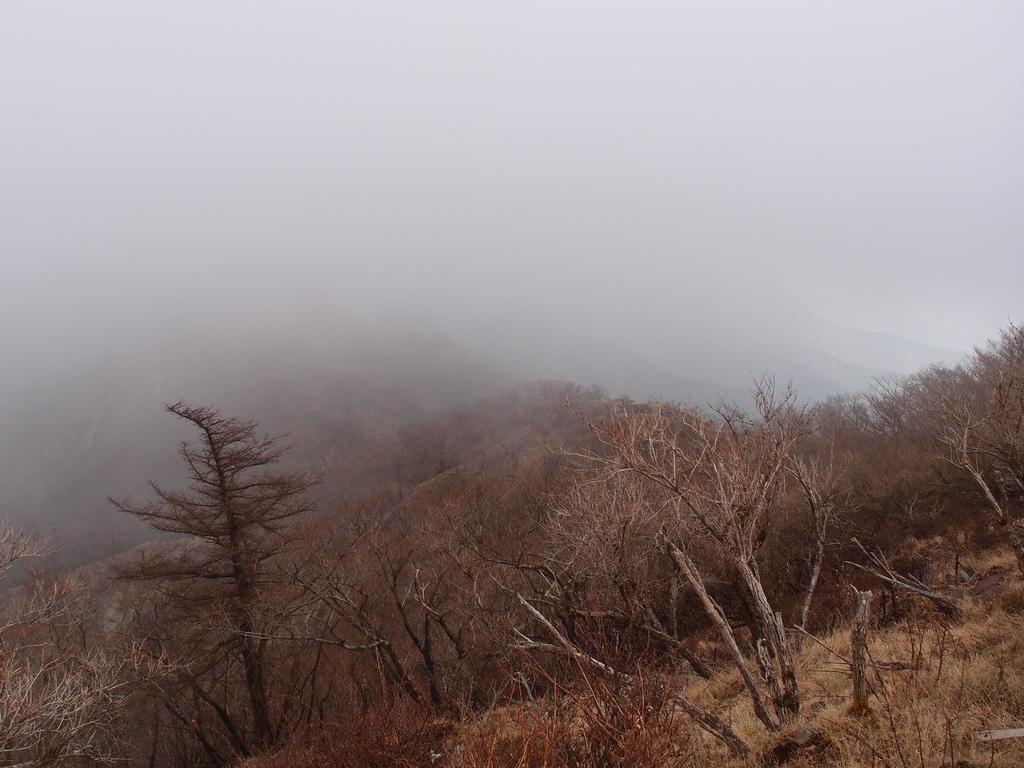Describe this image in one or two sentences. In this image we can see few hills. There are many trees in the image. We can see the fog in the image. 